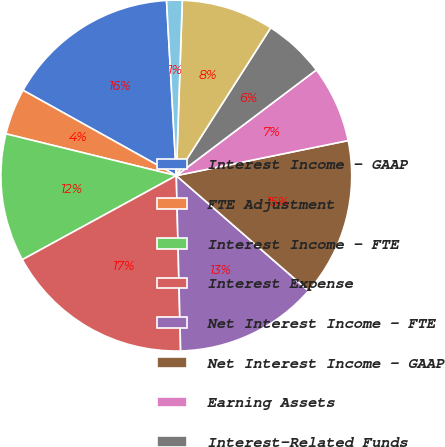<chart> <loc_0><loc_0><loc_500><loc_500><pie_chart><fcel>Interest Income - GAAP<fcel>FTE Adjustment<fcel>Interest Income - FTE<fcel>Interest Expense<fcel>Net Interest Income - FTE<fcel>Net Interest Income - GAAP<fcel>Earning Assets<fcel>Interest-Related Funds<fcel>Net Noninterest-Related Funds<fcel>Interest Rate Spread<nl><fcel>16.03%<fcel>4.26%<fcel>11.78%<fcel>17.44%<fcel>13.2%<fcel>14.61%<fcel>7.09%<fcel>5.67%<fcel>8.5%<fcel>1.43%<nl></chart> 